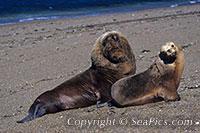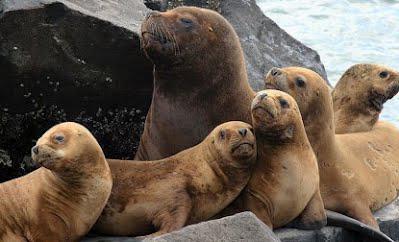The first image is the image on the left, the second image is the image on the right. Analyze the images presented: Is the assertion "One of the images shows exactly two sea lions." valid? Answer yes or no. Yes. The first image is the image on the left, the second image is the image on the right. Assess this claim about the two images: "One image shows exactly two seals, which are of different sizes.". Correct or not? Answer yes or no. Yes. 